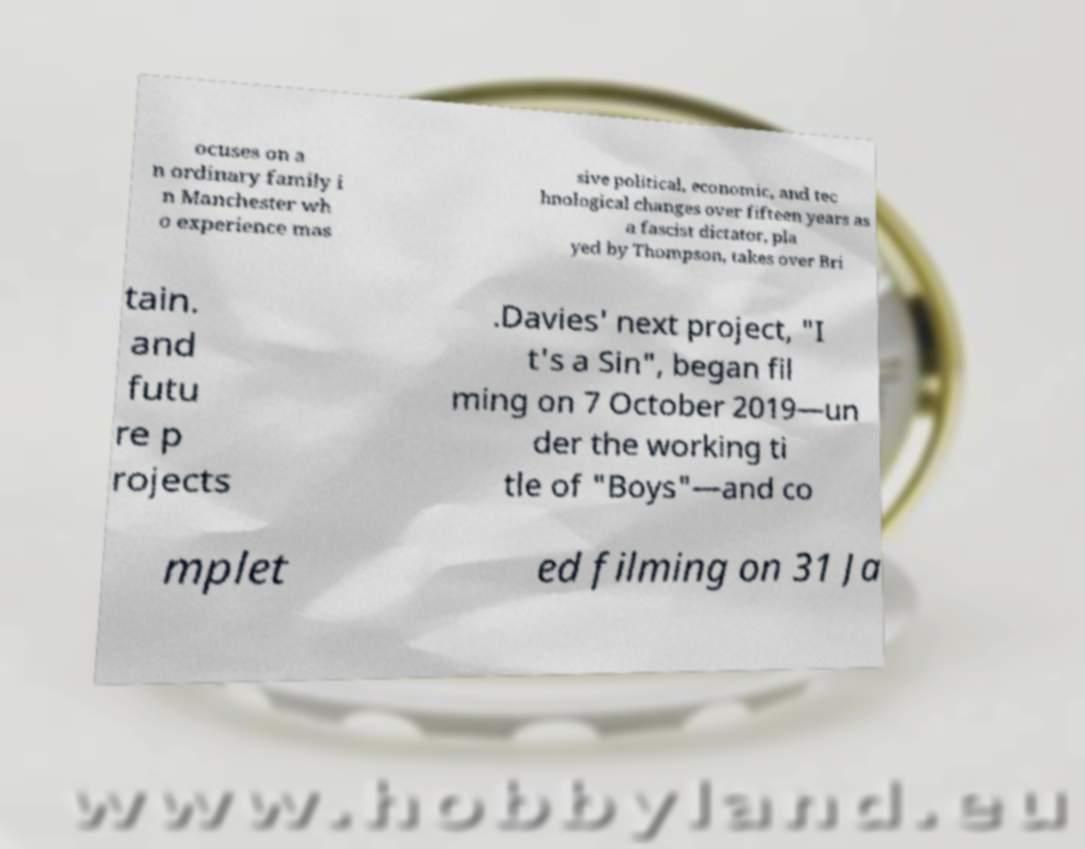What messages or text are displayed in this image? I need them in a readable, typed format. ocuses on a n ordinary family i n Manchester wh o experience mas sive political, economic, and tec hnological changes over fifteen years as a fascist dictator, pla yed by Thompson, takes over Bri tain. and futu re p rojects .Davies' next project, "I t's a Sin", began fil ming on 7 October 2019—un der the working ti tle of "Boys"—and co mplet ed filming on 31 Ja 